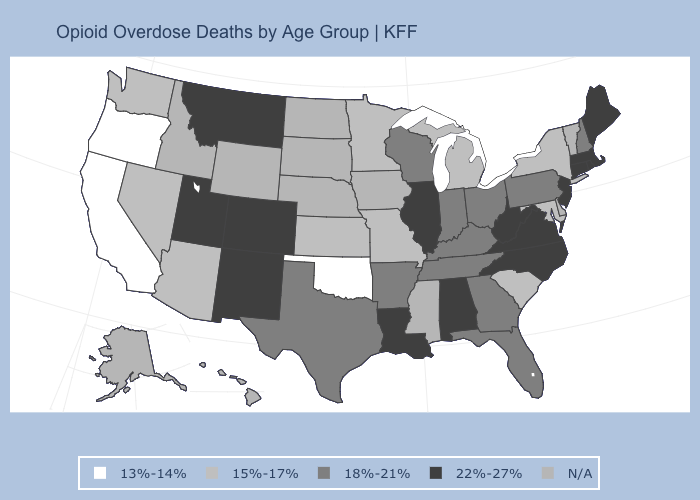What is the value of North Carolina?
Short answer required. 22%-27%. Which states have the lowest value in the USA?
Answer briefly. California, Oklahoma, Oregon. Among the states that border Texas , which have the highest value?
Give a very brief answer. Louisiana, New Mexico. Among the states that border Alabama , which have the highest value?
Keep it brief. Florida, Georgia, Tennessee. Name the states that have a value in the range N/A?
Concise answer only. Alaska, Delaware, Hawaii, Idaho, Iowa, Mississippi, Nebraska, North Dakota, South Dakota, Vermont, Wyoming. What is the highest value in states that border Tennessee?
Quick response, please. 22%-27%. What is the value of Mississippi?
Quick response, please. N/A. How many symbols are there in the legend?
Concise answer only. 5. Does Illinois have the highest value in the MidWest?
Quick response, please. Yes. What is the value of Washington?
Be succinct. 15%-17%. Does the first symbol in the legend represent the smallest category?
Answer briefly. Yes. What is the value of Indiana?
Write a very short answer. 18%-21%. What is the value of Oregon?
Keep it brief. 13%-14%. Does Oklahoma have the lowest value in the USA?
Short answer required. Yes. Name the states that have a value in the range 18%-21%?
Be succinct. Arkansas, Florida, Georgia, Indiana, Kentucky, New Hampshire, Ohio, Pennsylvania, Tennessee, Texas, Wisconsin. 